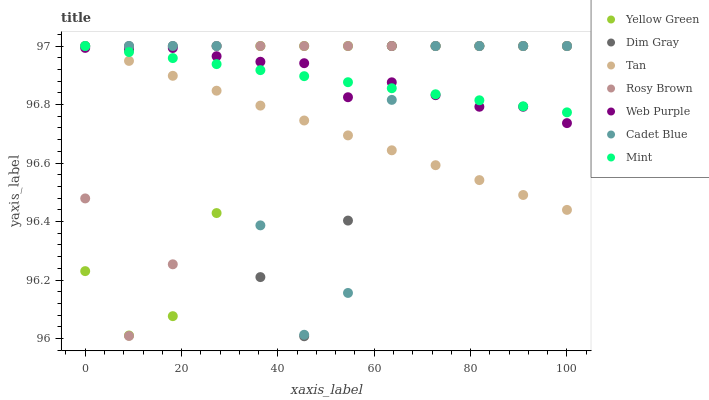Does Tan have the minimum area under the curve?
Answer yes or no. Yes. Does Web Purple have the maximum area under the curve?
Answer yes or no. Yes. Does Yellow Green have the minimum area under the curve?
Answer yes or no. No. Does Yellow Green have the maximum area under the curve?
Answer yes or no. No. Is Tan the smoothest?
Answer yes or no. Yes. Is Dim Gray the roughest?
Answer yes or no. Yes. Is Yellow Green the smoothest?
Answer yes or no. No. Is Yellow Green the roughest?
Answer yes or no. No. Does Dim Gray have the lowest value?
Answer yes or no. Yes. Does Yellow Green have the lowest value?
Answer yes or no. No. Does Mint have the highest value?
Answer yes or no. Yes. Does Web Purple have the highest value?
Answer yes or no. No. Does Dim Gray intersect Tan?
Answer yes or no. Yes. Is Dim Gray less than Tan?
Answer yes or no. No. Is Dim Gray greater than Tan?
Answer yes or no. No. 